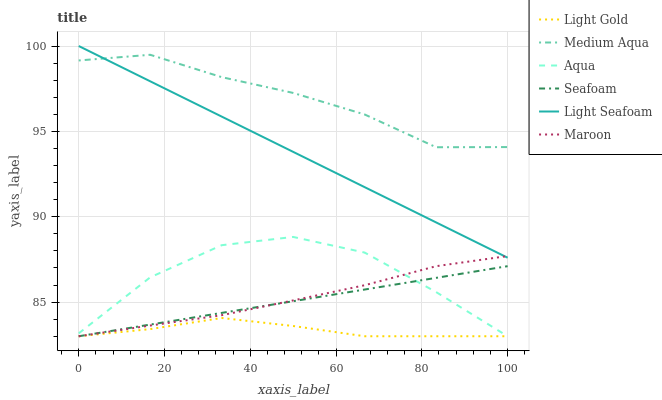Does Seafoam have the minimum area under the curve?
Answer yes or no. No. Does Seafoam have the maximum area under the curve?
Answer yes or no. No. Is Seafoam the smoothest?
Answer yes or no. No. Is Seafoam the roughest?
Answer yes or no. No. Does Medium Aqua have the lowest value?
Answer yes or no. No. Does Seafoam have the highest value?
Answer yes or no. No. Is Seafoam less than Light Seafoam?
Answer yes or no. Yes. Is Medium Aqua greater than Maroon?
Answer yes or no. Yes. Does Seafoam intersect Light Seafoam?
Answer yes or no. No. 